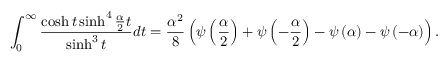Convert formula to latex. <formula><loc_0><loc_0><loc_500><loc_500>\int _ { 0 } ^ { \infty } \frac { \cosh t \sinh ^ { 4 } \frac { \alpha } { 2 } t } { \sinh ^ { 3 } t } d t = \frac { \alpha ^ { 2 } } { 8 } \left ( \psi \left ( \frac { \alpha } { 2 } \right ) + \psi \left ( - \frac { \alpha } { 2 } \right ) - \psi \left ( \alpha \right ) - \psi \left ( - \alpha \right ) \right ) .</formula> 